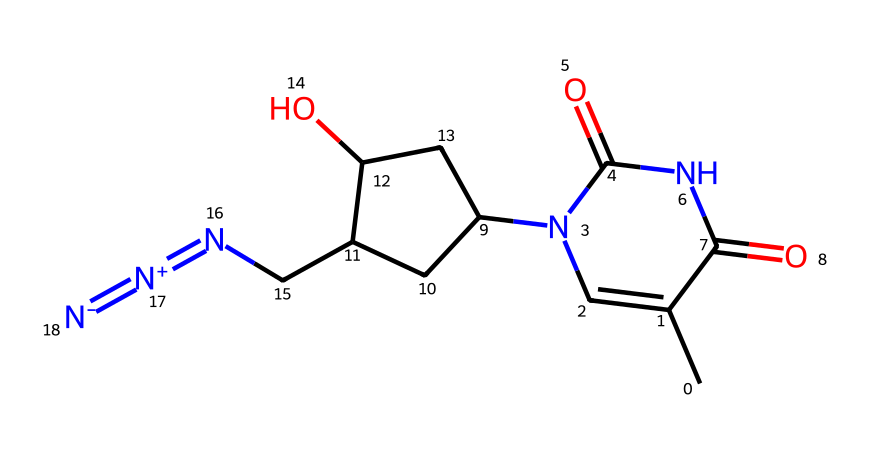What is the molecular formula of azidothymidine (AZT)? To find the molecular formula, count the types and numbers of atoms present in the SMILES representation. There are 12 carbon (C) atoms, 15 hydrogen (H) atoms, 6 nitrogen (N) atoms, and 4 oxygen (O) atoms. Thus, the molecular formula is C10H13N5O4.
Answer: C10H13N5O4 How many nitrogen atoms are in azidothymidine? The SMILES notation shows multiple nitrogen atoms; by counting the symbols "N" in the representation, we find there are 5 nitrogen atoms present.
Answer: 5 What functional group is represented by the group "CN=[N+]=[N-]"? This part of the SMILES depicts the azide group, characterized by the nitrogen-nitrogen triple bond and positive-negative charge separation, specifically indicating the presence of an azide functional group here.
Answer: Azide How many rings are present in the structure of AZT? Analyzing the ring structures, we notice a cyclic compound with two distinct rings present in the SMILES representation (the pyrimidine ring and the piperidine ring).
Answer: 2 What type of compound is azidothymidine classified as? Based on its structure and functionality, AZT is classified as an antiretroviral medication, specifically a nucleoside reverse transcriptase inhibitor (NRTI), used to treat HIV.
Answer: NRTI What role does the azide group play in inhibiting reverse transcriptase? The azide group is crucial for the drug's mechanism, allowing AZT to mimic nucleotides and be incorporated into viral DNA during replication, ultimately causing termination of chain elongation.
Answer: Termination What type of bond exists between the nitrogen atoms in the azide functional group? The nitrogen atoms in the azide group are joined by a triple bond, providing stability and specific reactivity crucial for the action of AZT against the HIV virus.
Answer: Triple bond 